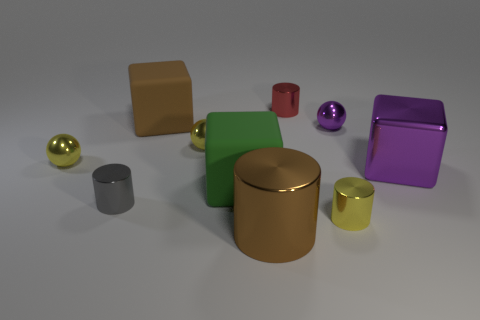Is the color of the large metallic thing in front of the gray thing the same as the large block that is behind the large purple shiny thing?
Provide a short and direct response. Yes. How many large matte things are to the left of the brown cylinder?
Provide a succinct answer. 2. Are there any big matte objects that are in front of the tiny metallic cylinder that is behind the big brown object that is behind the brown shiny thing?
Your response must be concise. Yes. What number of brown matte objects are the same size as the purple shiny cube?
Ensure brevity in your answer.  1. There is a big green thing left of the cylinder that is to the right of the red metallic cylinder; what is its material?
Make the answer very short. Rubber. What is the shape of the yellow metal thing that is to the right of the tiny shiny object that is behind the ball that is to the right of the green rubber cube?
Your response must be concise. Cylinder. There is a small gray object left of the tiny red cylinder; is it the same shape as the yellow object on the right side of the large brown metal cylinder?
Ensure brevity in your answer.  Yes. What number of other things are made of the same material as the tiny purple ball?
Provide a succinct answer. 7. What shape is the other object that is the same material as the large green thing?
Ensure brevity in your answer.  Cube. Do the green matte block and the red metal cylinder have the same size?
Provide a succinct answer. No. 